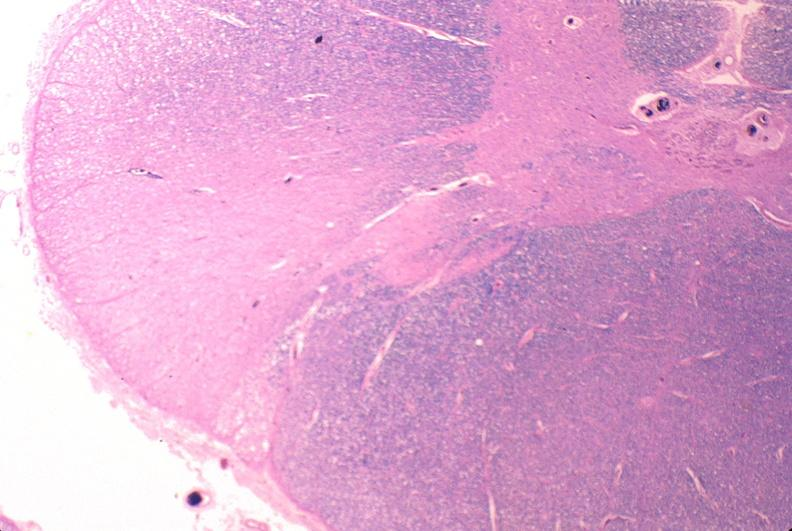s nervous present?
Answer the question using a single word or phrase. Yes 